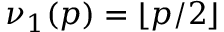<formula> <loc_0><loc_0><loc_500><loc_500>\nu _ { 1 } ( p ) = \lfloor p / 2 \rfloor</formula> 